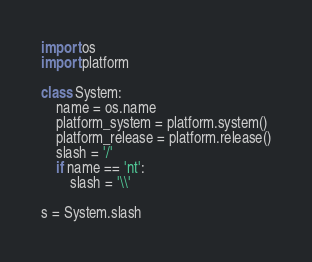<code> <loc_0><loc_0><loc_500><loc_500><_Python_>import os
import platform

class System:
    name = os.name
    platform_system = platform.system()
    platform_release = platform.release()
    slash = '/'
    if name == 'nt':
        slash = '\\'

s = System.slash</code> 